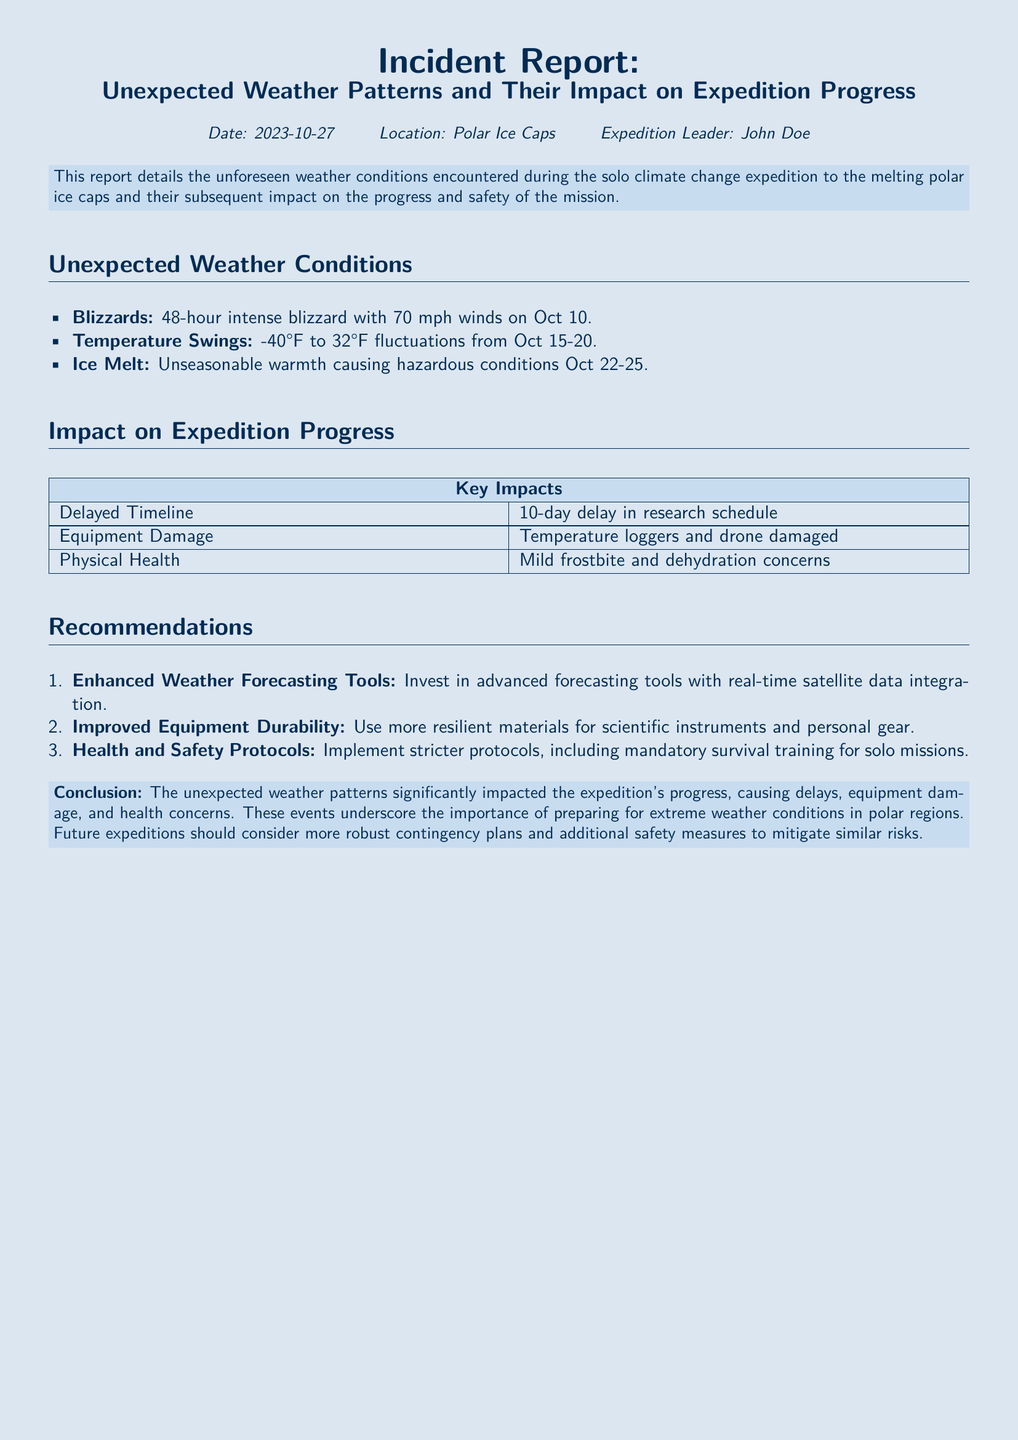What date was the incident report issued? The report was issued on October 27, 2023.
Answer: October 27, 2023 Who is the expedition leader? The expedition leader mentioned in the report is John Doe.
Answer: John Doe How long did the intense blizzard last? The blizzard lasted for 48 hours, starting on October 10.
Answer: 48 hours What was the temperature range from October 15 to 20? The temperature ranged from -40°F to 32°F during that period.
Answer: -40°F to 32°F What caused hazardous conditions from October 22 to 25? The report indicates that unseasonable warmth caused hazardous conditions during this time.
Answer: Unseasonable warmth What is one of the impacts on equipment? The report states that temperature loggers and a drone were damaged.
Answer: Damaged temperature loggers and drone How many days was the research schedule delayed? The research schedule experienced a delay of 10 days.
Answer: 10 days What is a recommended tool to mitigate weather challenges? The report recommends investing in advanced weather forecasting tools.
Answer: Advanced weather forecasting tools What is a suggested safety protocol for solo missions? The report suggests implementing mandatory survival training for solo missions.
Answer: Mandatory survival training 